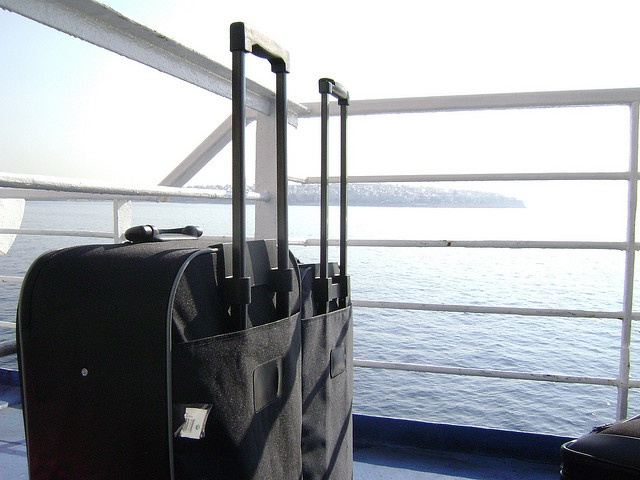Describe the objects in this image and their specific colors. I can see a suitcase in darkgray, black, gray, and white tones in this image. 